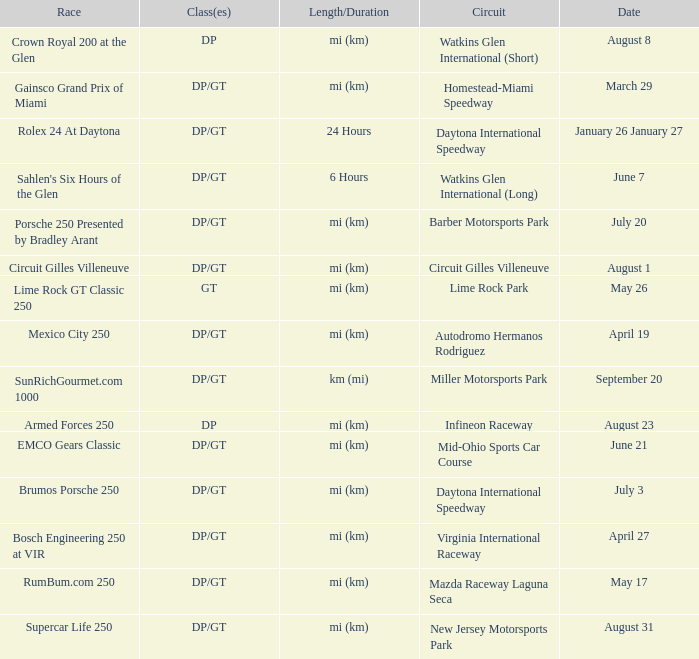What is the length and duration of the race on April 19? Mi (km). 